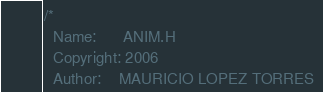<code> <loc_0><loc_0><loc_500><loc_500><_C_>/*
  Name:      ANIM.H 
  Copyright: 2006
  Author:    MAURICIO LOPEZ TORRES </code> 